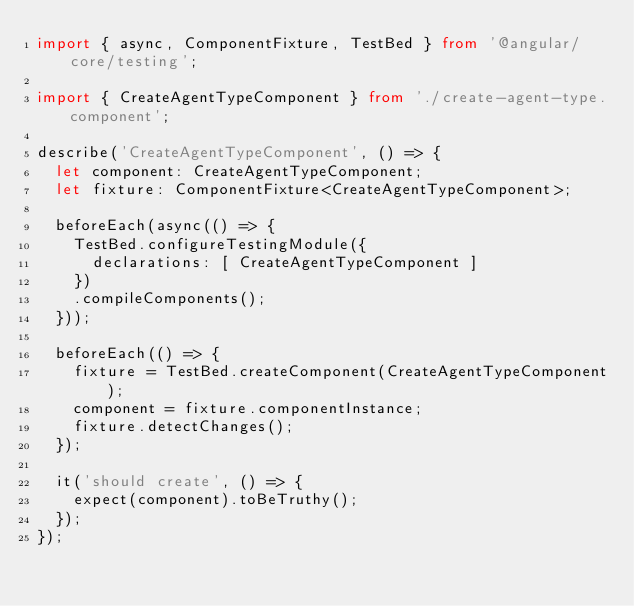Convert code to text. <code><loc_0><loc_0><loc_500><loc_500><_TypeScript_>import { async, ComponentFixture, TestBed } from '@angular/core/testing';

import { CreateAgentTypeComponent } from './create-agent-type.component';

describe('CreateAgentTypeComponent', () => {
  let component: CreateAgentTypeComponent;
  let fixture: ComponentFixture<CreateAgentTypeComponent>;

  beforeEach(async(() => {
    TestBed.configureTestingModule({
      declarations: [ CreateAgentTypeComponent ]
    })
    .compileComponents();
  }));

  beforeEach(() => {
    fixture = TestBed.createComponent(CreateAgentTypeComponent);
    component = fixture.componentInstance;
    fixture.detectChanges();
  });

  it('should create', () => {
    expect(component).toBeTruthy();
  });
});
</code> 